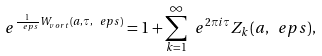Convert formula to latex. <formula><loc_0><loc_0><loc_500><loc_500>\ e ^ { \frac { 1 } { \ e p s } W _ { v o r t } ( a , \tau , \ e p s ) } = 1 + \sum _ { k = 1 } ^ { \infty } \ e ^ { 2 \pi i \tau } Z _ { k } ( a , \ e p s ) ,</formula> 